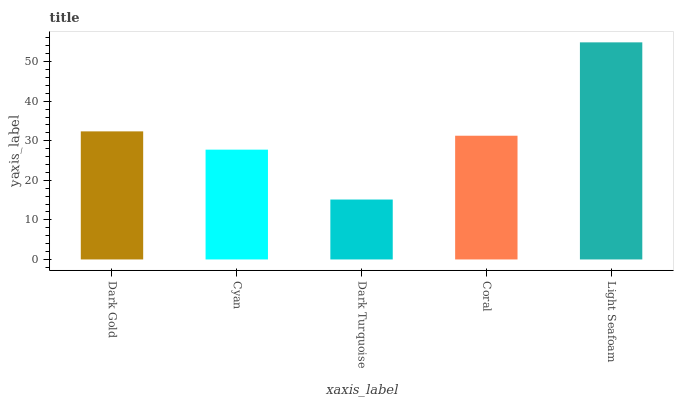Is Cyan the minimum?
Answer yes or no. No. Is Cyan the maximum?
Answer yes or no. No. Is Dark Gold greater than Cyan?
Answer yes or no. Yes. Is Cyan less than Dark Gold?
Answer yes or no. Yes. Is Cyan greater than Dark Gold?
Answer yes or no. No. Is Dark Gold less than Cyan?
Answer yes or no. No. Is Coral the high median?
Answer yes or no. Yes. Is Coral the low median?
Answer yes or no. Yes. Is Cyan the high median?
Answer yes or no. No. Is Cyan the low median?
Answer yes or no. No. 